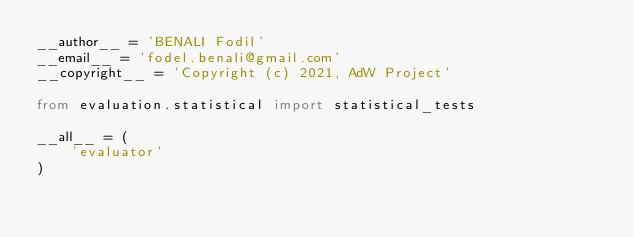Convert code to text. <code><loc_0><loc_0><loc_500><loc_500><_Python_>__author__ = 'BENALI Fodil'
__email__ = 'fodel.benali@gmail.com'
__copyright__ = 'Copyright (c) 2021, AdW Project'

from evaluation.statistical import statistical_tests

__all__ = (
    'evaluator'
)
</code> 